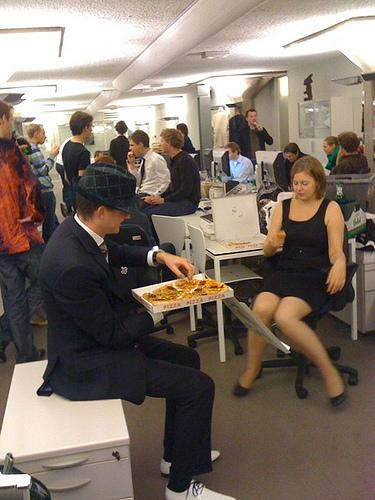Where are people here eating pizza today?

Choices:
A) icecream shop
B) pizzeria
C) office setting
D) malt shop office setting 